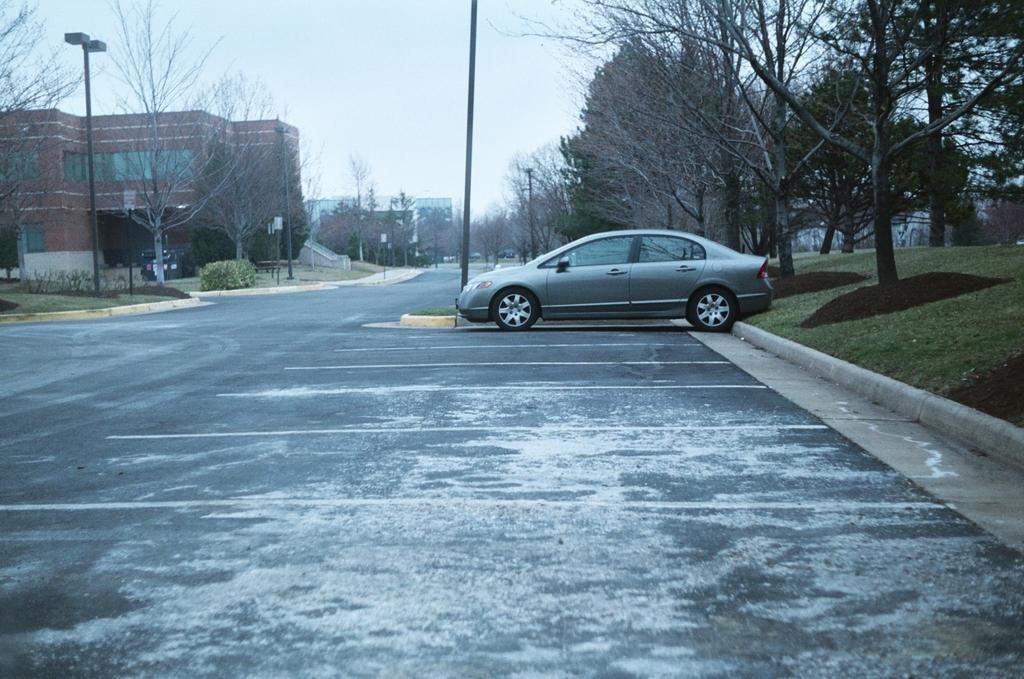Could you give a brief overview of what you see in this image? In the center of the image we can see a car parked in the parking lot. In the background, we can see a group of trees, poles, building and the sky. 